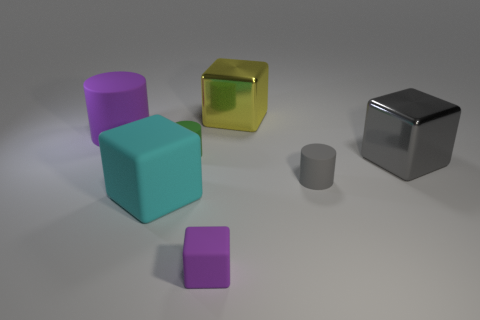What is the shape of the big purple object that is made of the same material as the large cyan thing?
Give a very brief answer. Cylinder. Is there any other thing that has the same shape as the big cyan matte object?
Offer a terse response. Yes. Are the purple object that is in front of the tiny gray cylinder and the big purple cylinder made of the same material?
Give a very brief answer. Yes. What material is the cylinder right of the yellow metallic block?
Offer a terse response. Rubber. How big is the purple thing that is behind the purple object that is in front of the cyan matte block?
Give a very brief answer. Large. How many purple rubber objects have the same size as the green rubber thing?
Make the answer very short. 1. Does the big object right of the yellow shiny thing have the same color as the tiny matte object in front of the big cyan matte object?
Provide a short and direct response. No. There is a green rubber thing; are there any tiny cylinders in front of it?
Offer a very short reply. Yes. There is a large thing that is both right of the purple cube and in front of the yellow cube; what color is it?
Offer a terse response. Gray. Is there a large metallic object that has the same color as the large matte cylinder?
Make the answer very short. No. 